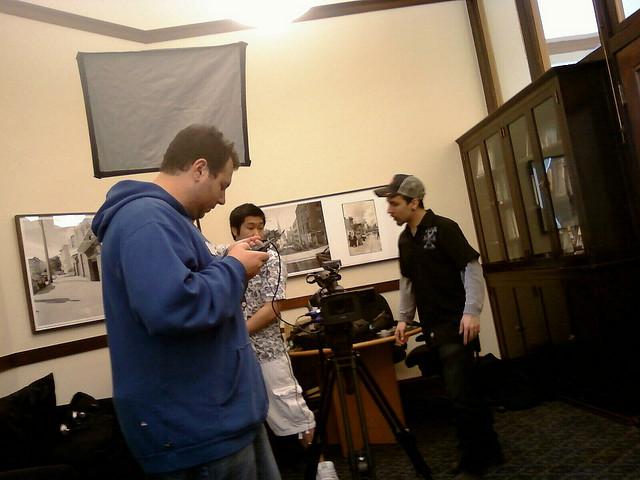What is the man on the left opening?
Answer briefly. Phone. How many men are in the picture?
Give a very brief answer. 3. What is he holding?
Short answer required. Phone. What is the man in the foreground doing?
Give a very brief answer. Texting. What color is the hoodie in the picture?
Be succinct. Blue. 